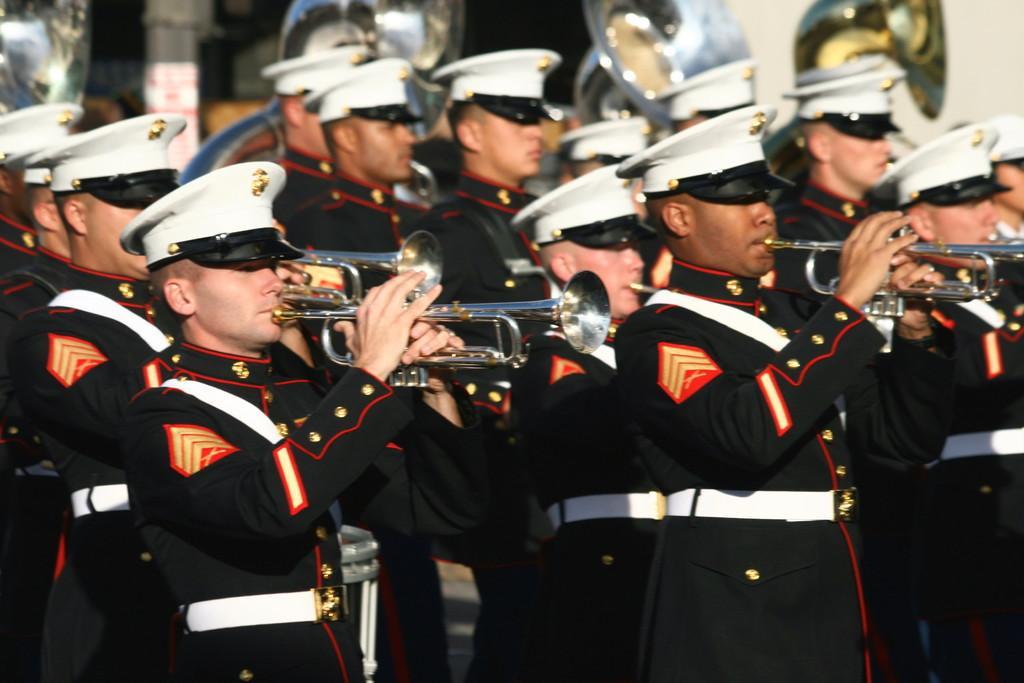In one or two sentences, can you explain what this image depicts? In the center of the image we can see persons walking on the road and holding musical instruments. 